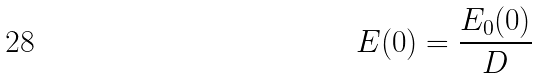<formula> <loc_0><loc_0><loc_500><loc_500>E ( 0 ) = \frac { E _ { 0 } ( 0 ) } { D }</formula> 